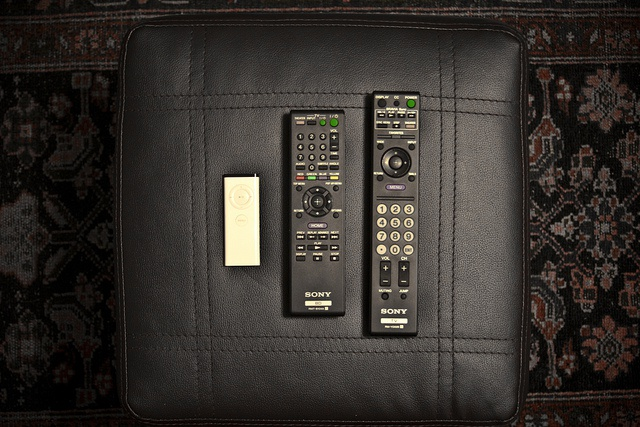Describe the objects in this image and their specific colors. I can see remote in black, gray, khaki, and darkgray tones and remote in black, gray, and khaki tones in this image. 